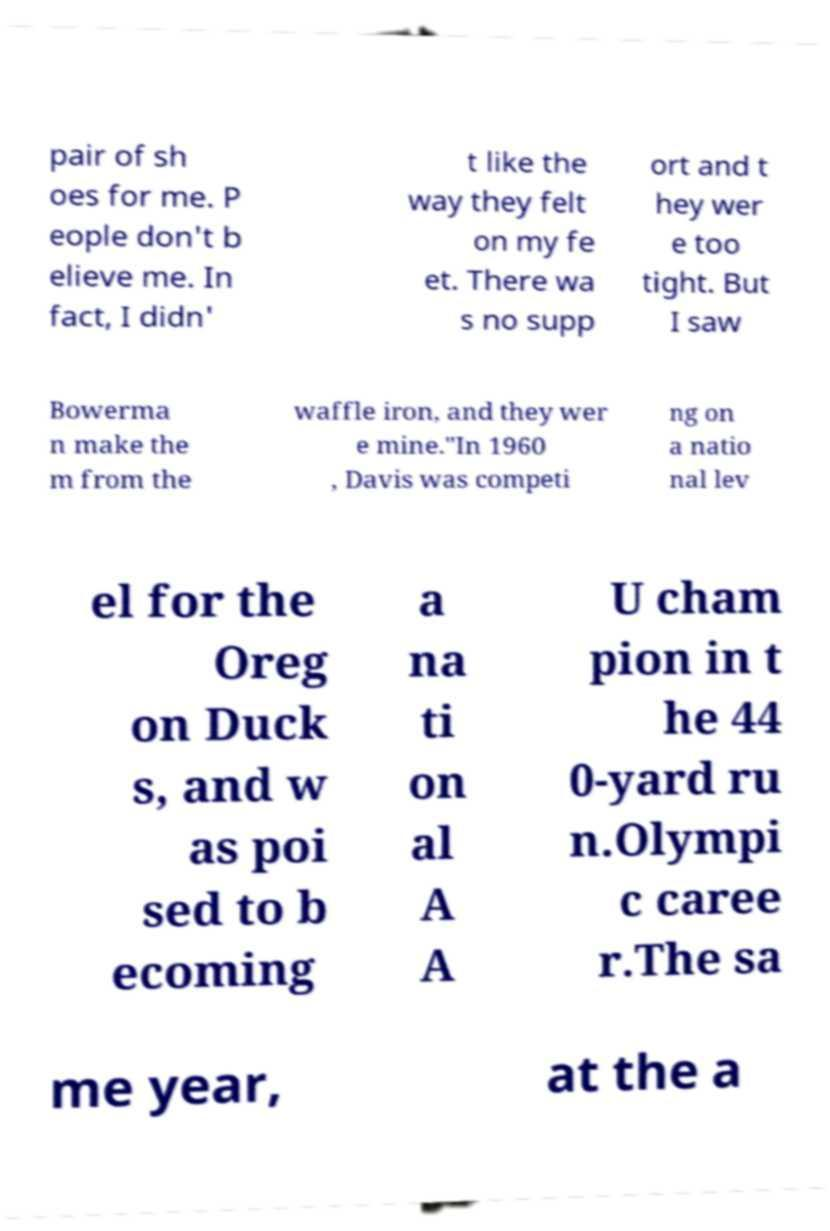Please identify and transcribe the text found in this image. pair of sh oes for me. P eople don't b elieve me. In fact, I didn' t like the way they felt on my fe et. There wa s no supp ort and t hey wer e too tight. But I saw Bowerma n make the m from the waffle iron, and they wer e mine."In 1960 , Davis was competi ng on a natio nal lev el for the Oreg on Duck s, and w as poi sed to b ecoming a na ti on al A A U cham pion in t he 44 0-yard ru n.Olympi c caree r.The sa me year, at the a 